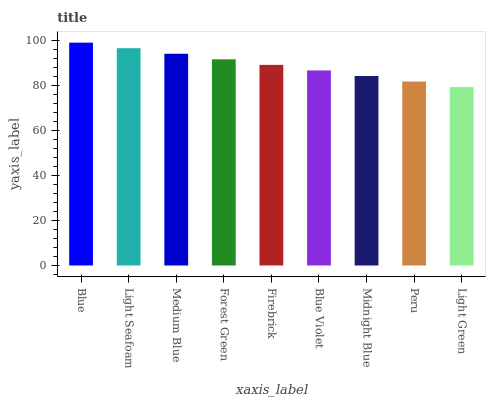Is Light Green the minimum?
Answer yes or no. Yes. Is Blue the maximum?
Answer yes or no. Yes. Is Light Seafoam the minimum?
Answer yes or no. No. Is Light Seafoam the maximum?
Answer yes or no. No. Is Blue greater than Light Seafoam?
Answer yes or no. Yes. Is Light Seafoam less than Blue?
Answer yes or no. Yes. Is Light Seafoam greater than Blue?
Answer yes or no. No. Is Blue less than Light Seafoam?
Answer yes or no. No. Is Firebrick the high median?
Answer yes or no. Yes. Is Firebrick the low median?
Answer yes or no. Yes. Is Midnight Blue the high median?
Answer yes or no. No. Is Blue Violet the low median?
Answer yes or no. No. 